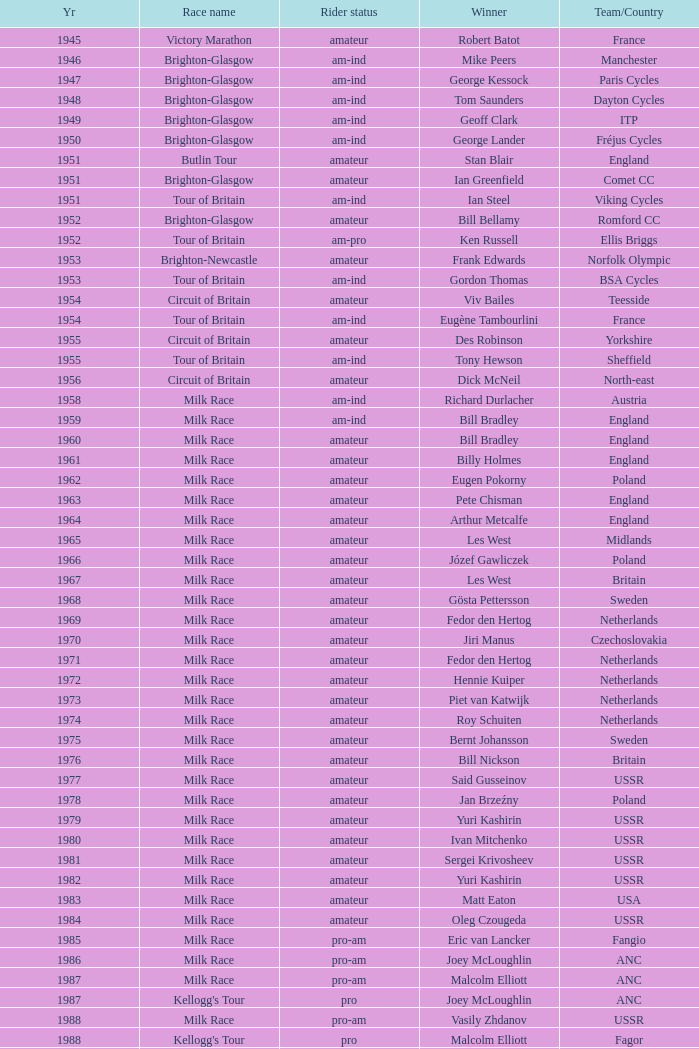What is the rider status for the 1971 netherlands team? Amateur. 